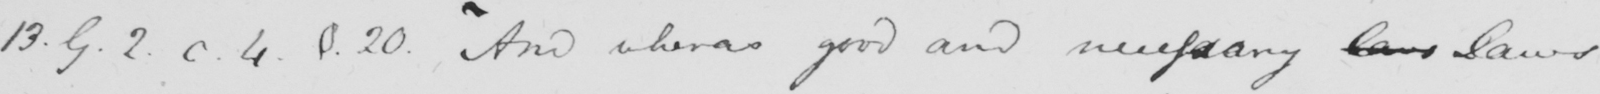Can you read and transcribe this handwriting? 13.9.2.c.4.§.20 .  ' And whereas good and necessary laws Laws 